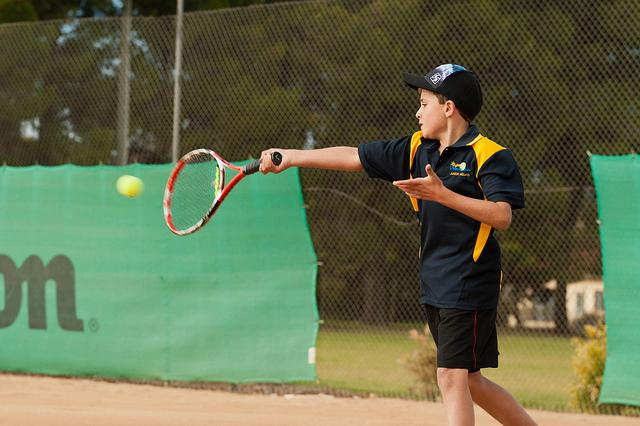Why are there letters on the green banners?

Choices:
A) rules regulations
B) sign-ups
C) directions
D) company sponsorships company sponsorships 